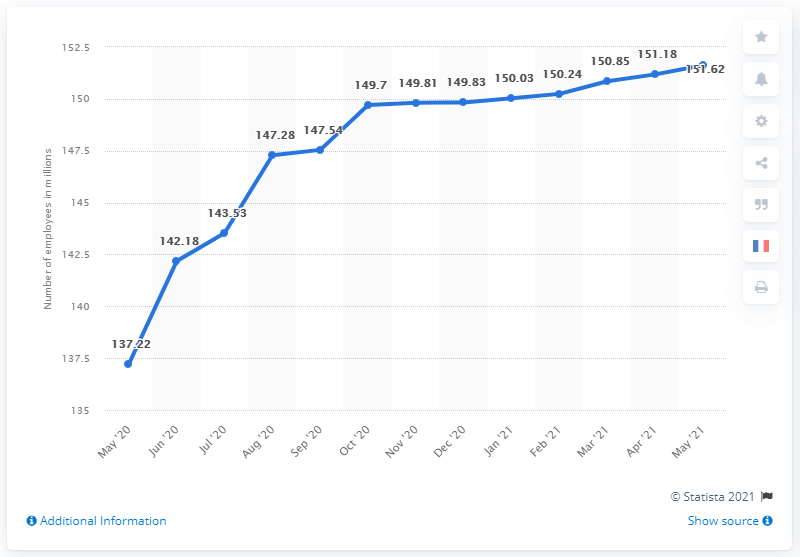Give some essential details in this illustration. In May 2021, there were 151.62 people employed in the United States. 